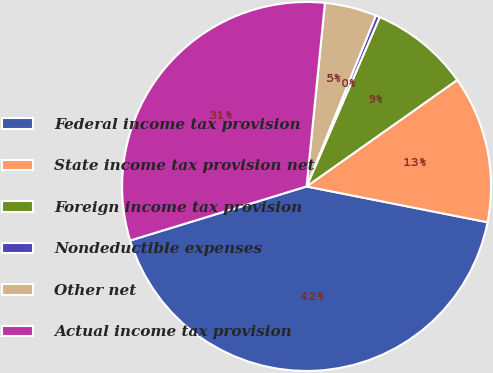Convert chart to OTSL. <chart><loc_0><loc_0><loc_500><loc_500><pie_chart><fcel>Federal income tax provision<fcel>State income tax provision net<fcel>Foreign income tax provision<fcel>Nondeductible expenses<fcel>Other net<fcel>Actual income tax provision<nl><fcel>42.16%<fcel>12.9%<fcel>8.72%<fcel>0.36%<fcel>4.54%<fcel>31.32%<nl></chart> 